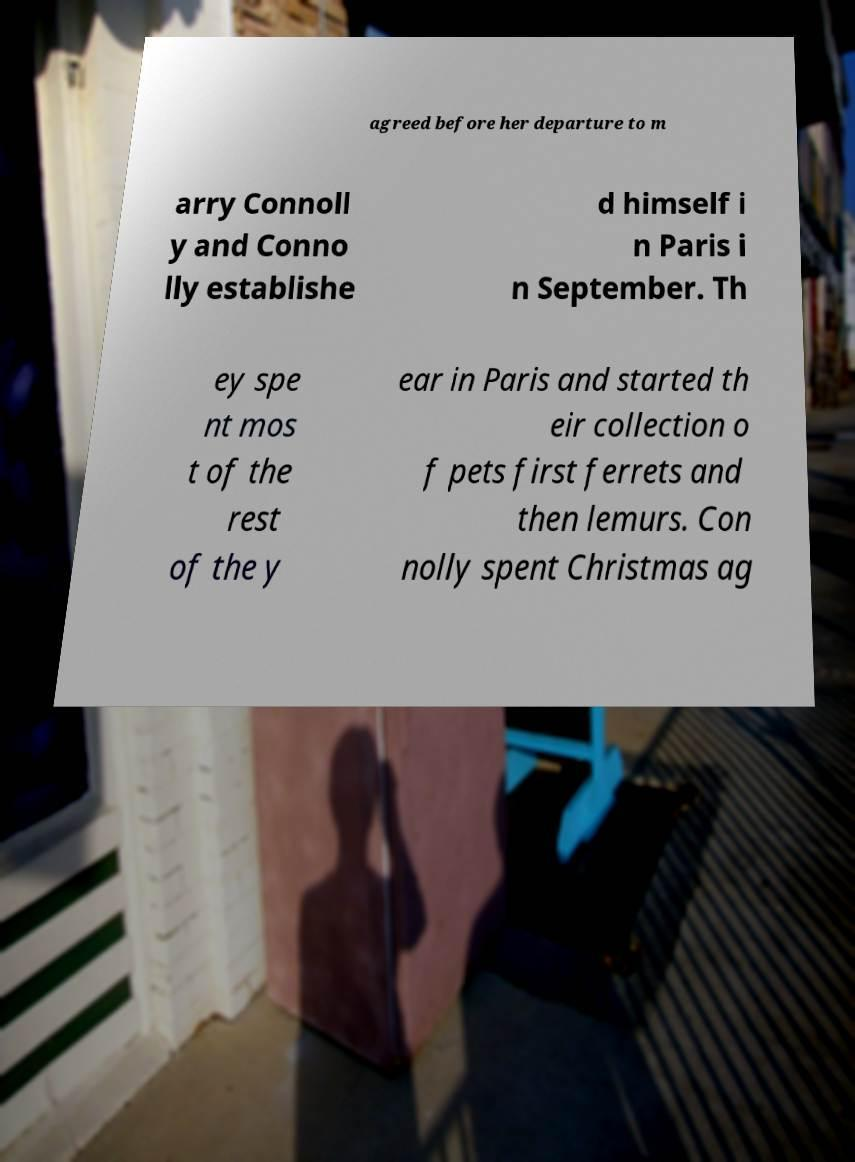Can you accurately transcribe the text from the provided image for me? agreed before her departure to m arry Connoll y and Conno lly establishe d himself i n Paris i n September. Th ey spe nt mos t of the rest of the y ear in Paris and started th eir collection o f pets first ferrets and then lemurs. Con nolly spent Christmas ag 